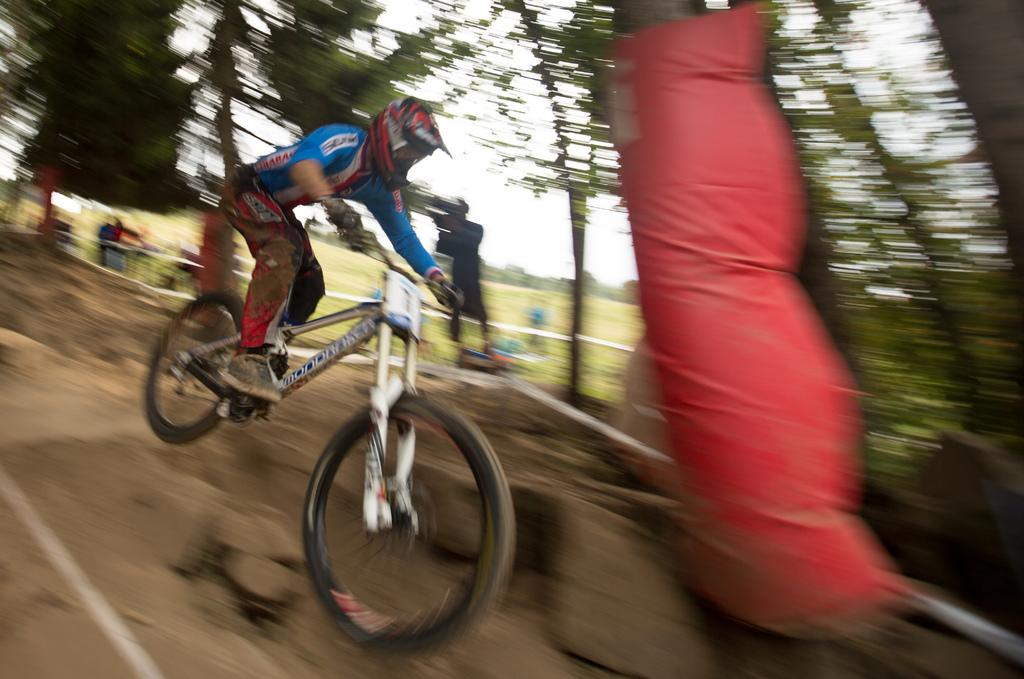What is the main subject of the image? There is a man in the image. What is the man doing in the image? The man is riding a cycle. What color is the t-shirt the man is wearing? The man is wearing a blue t-shirt. What type of yoke is the man using to rub his throat in the image? There is no yoke or rubbing of the throat depicted in the image; the man is simply riding a cycle while wearing a blue t-shirt. 